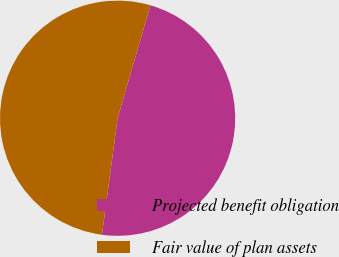<chart> <loc_0><loc_0><loc_500><loc_500><pie_chart><fcel>Projected benefit obligation<fcel>Fair value of plan assets<nl><fcel>47.62%<fcel>52.38%<nl></chart> 